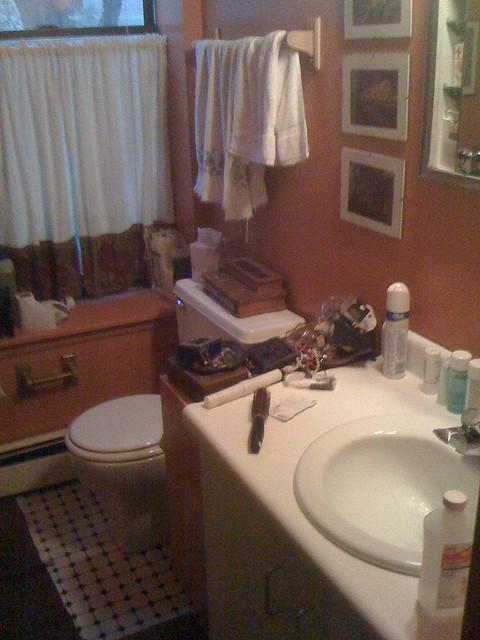What is on the bathroom sink?
Be succinct. Toiletries. What color is the towel above the toilet?
Answer briefly. White. Where is the curtain?
Quick response, please. Window. What color is the sink under the mirror?
Concise answer only. White. 